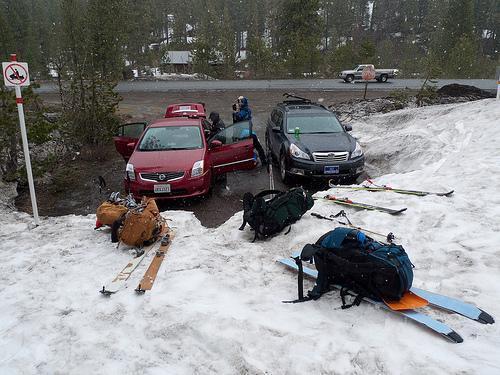How many sets of skis are there?
Give a very brief answer. 3. How many vehicles are there?
Give a very brief answer. 3. 